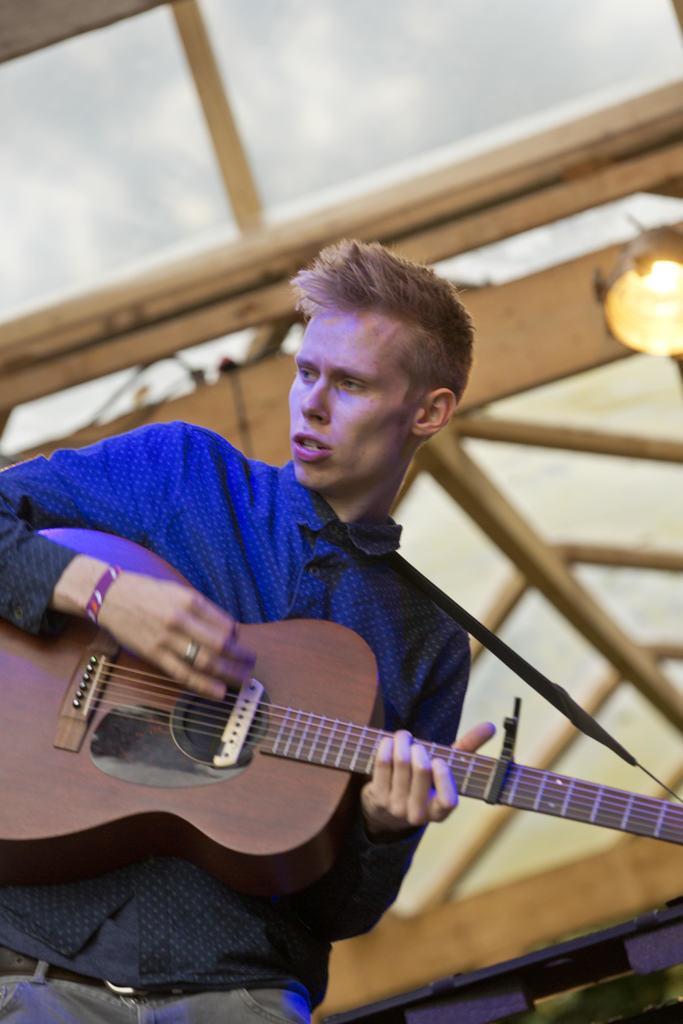Please provide a concise description of this image. In this image, There is a boy standing and he is holding some music instrument which is in brown color, In the background there are some yellow color block an there is a light in yellow color. 